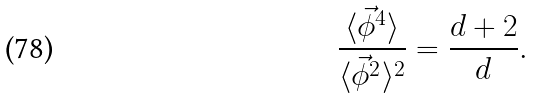<formula> <loc_0><loc_0><loc_500><loc_500>\frac { \langle \vec { \phi } ^ { 4 } \rangle } { \langle \vec { \phi } ^ { 2 } \rangle ^ { 2 } } = \frac { d + 2 } { d } .</formula> 